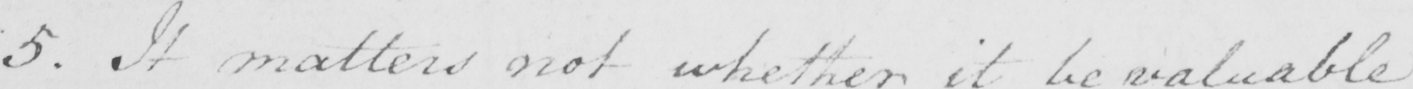Transcribe the text shown in this historical manuscript line. 5 . It matters not whether it be valuable 